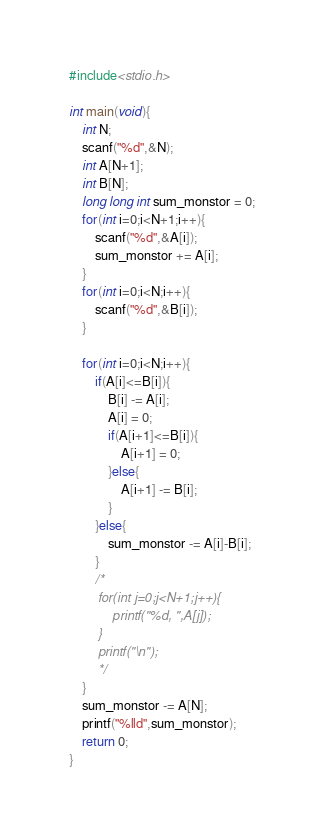<code> <loc_0><loc_0><loc_500><loc_500><_C_>#include<stdio.h>

int main(void){
    int N;
    scanf("%d",&N);
    int A[N+1];
    int B[N];
    long long int sum_monstor = 0;
    for(int i=0;i<N+1;i++){
        scanf("%d",&A[i]);
        sum_monstor += A[i];
    }
    for(int i=0;i<N;i++){
        scanf("%d",&B[i]);
    }
    
    for(int i=0;i<N;i++){
        if(A[i]<=B[i]){
            B[i] -= A[i];
            A[i] = 0;
            if(A[i+1]<=B[i]){
                A[i+1] = 0;
            }else{
                A[i+1] -= B[i];
            }
        }else{
            sum_monstor -= A[i]-B[i];
        }
        /*
        for(int j=0;j<N+1;j++){
            printf("%d, ",A[j]);
        }
        printf("\n");
        */
    }
    sum_monstor -= A[N];
    printf("%lld",sum_monstor);
    return 0;
}</code> 